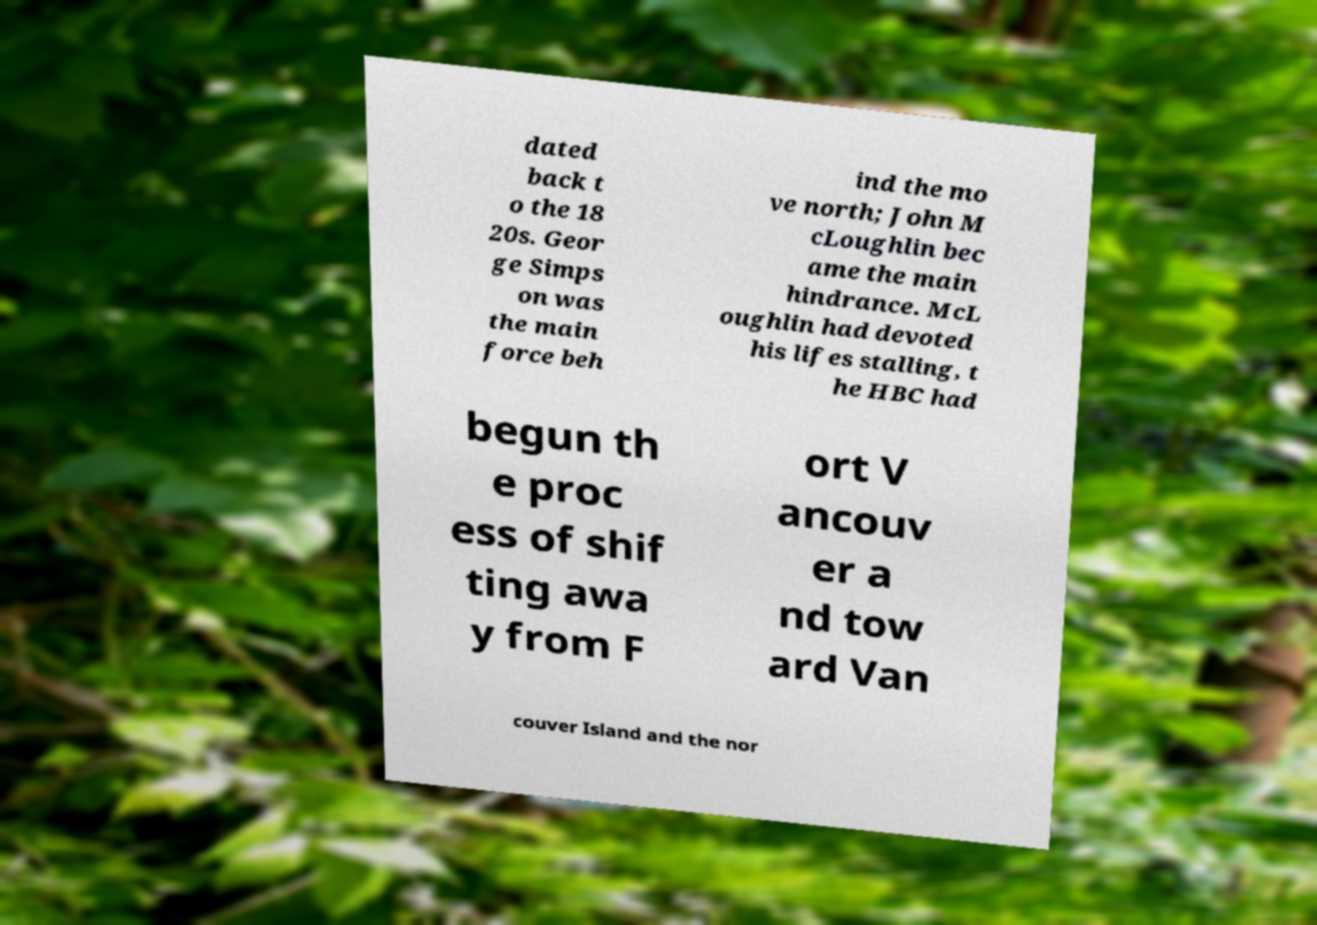Can you read and provide the text displayed in the image?This photo seems to have some interesting text. Can you extract and type it out for me? dated back t o the 18 20s. Geor ge Simps on was the main force beh ind the mo ve north; John M cLoughlin bec ame the main hindrance. McL oughlin had devoted his lifes stalling, t he HBC had begun th e proc ess of shif ting awa y from F ort V ancouv er a nd tow ard Van couver Island and the nor 